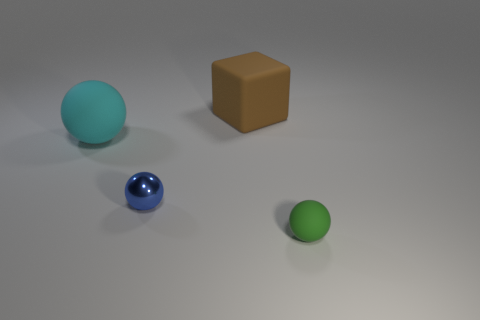Is there anything else that has the same material as the blue sphere?
Provide a short and direct response. No. There is another metallic thing that is the same size as the green thing; what color is it?
Offer a terse response. Blue. How many tiny matte spheres are in front of the matte sphere left of the big brown rubber object?
Ensure brevity in your answer.  1. What number of things are either large rubber objects to the left of the small blue object or large gray shiny cubes?
Make the answer very short. 1. What number of green balls have the same material as the large brown object?
Keep it short and to the point. 1. Are there an equal number of metallic objects to the right of the large matte block and small blue metal objects?
Your answer should be very brief. No. How big is the object that is in front of the small blue shiny thing?
Provide a succinct answer. Small. What number of tiny objects are either cyan matte spheres or purple metallic balls?
Make the answer very short. 0. The other small object that is the same shape as the tiny blue object is what color?
Offer a very short reply. Green. Does the cyan rubber thing have the same size as the green rubber thing?
Your response must be concise. No. 